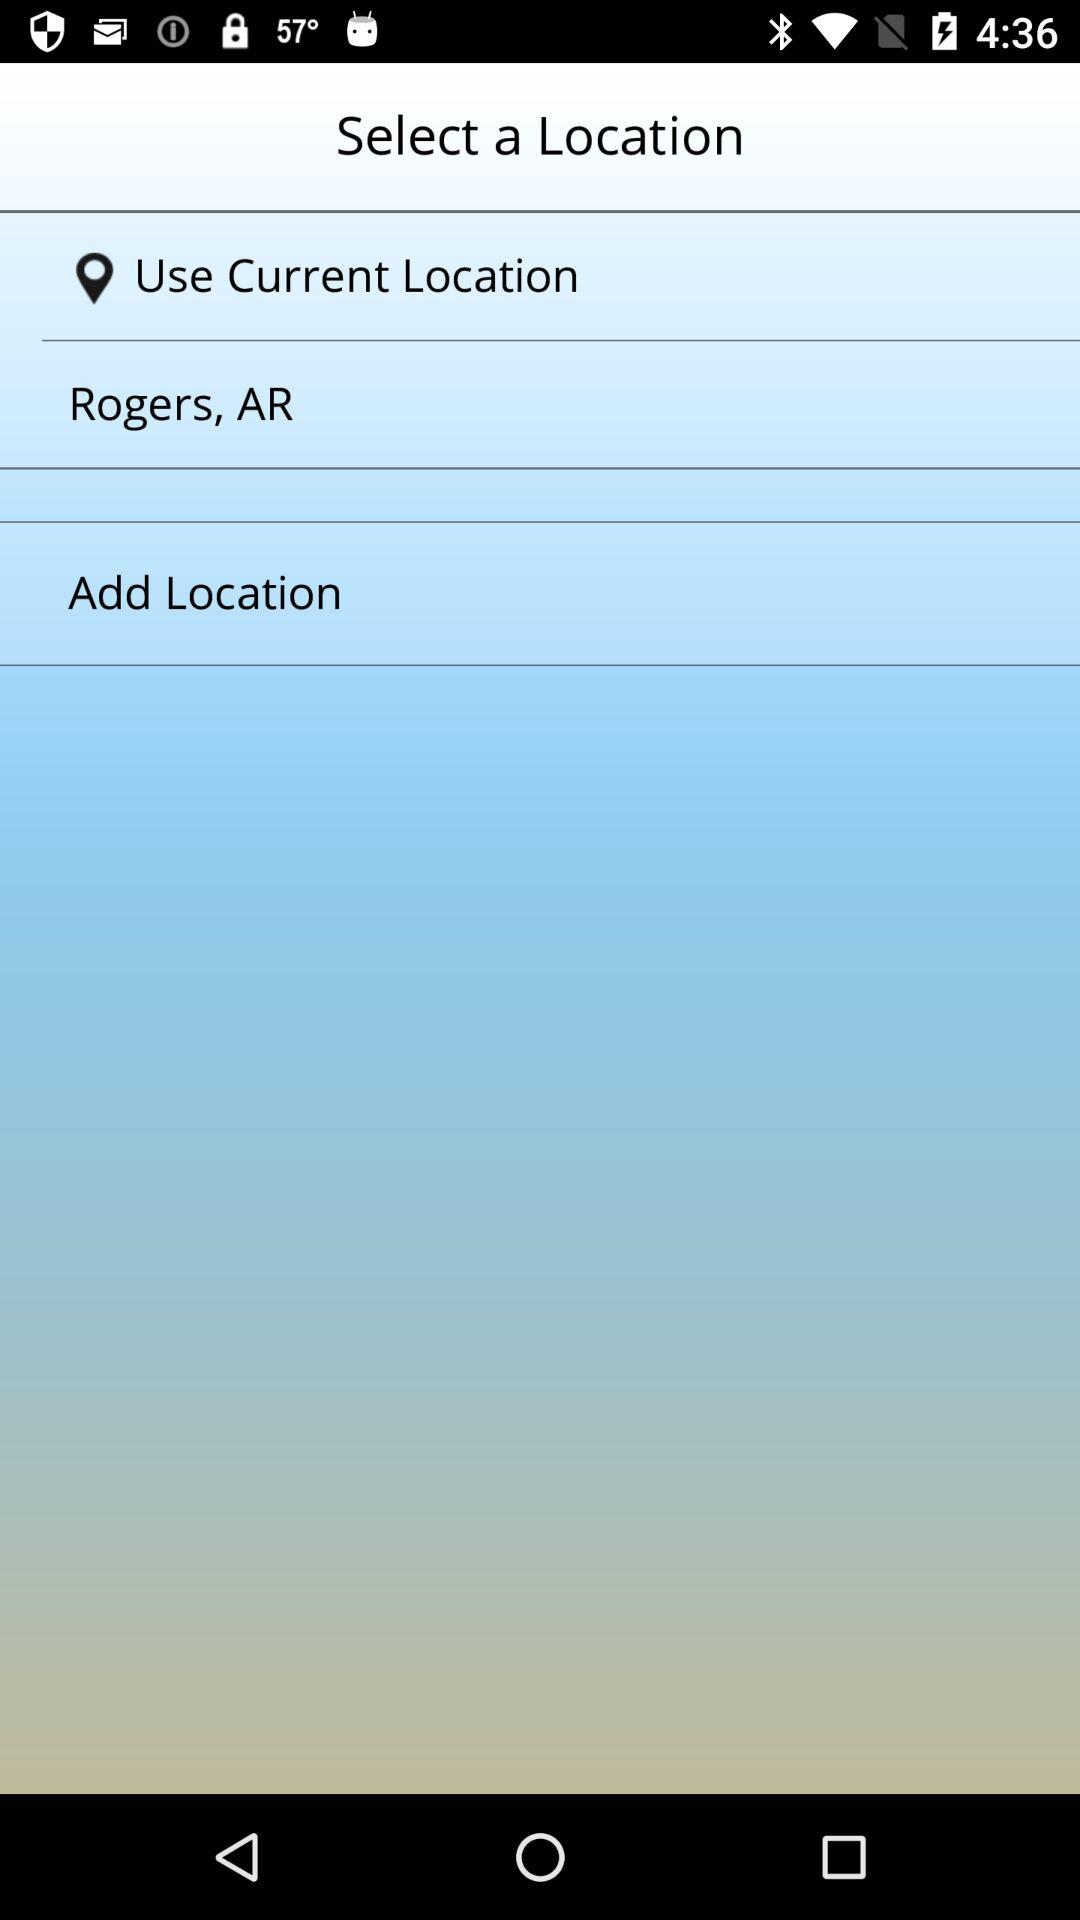What is the mentioned location? The mentioned location is Rogers, AR. 